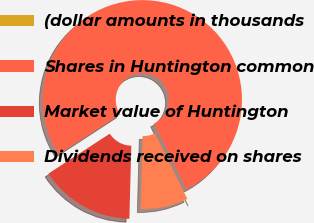Convert chart to OTSL. <chart><loc_0><loc_0><loc_500><loc_500><pie_chart><fcel>(dollar amounts in thousands<fcel>Shares in Huntington common<fcel>Market value of Huntington<fcel>Dividends received on shares<nl><fcel>0.01%<fcel>76.9%<fcel>15.39%<fcel>7.7%<nl></chart> 